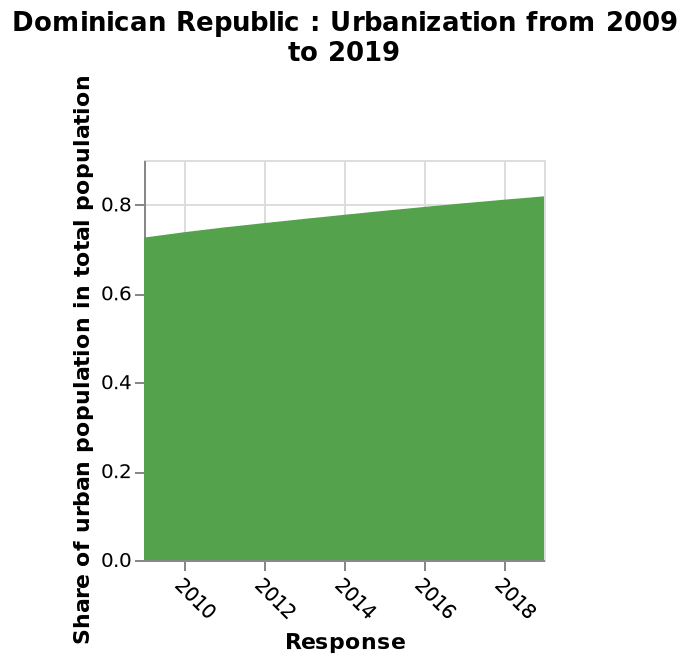<image>
How much has the share of urban population increased over the last 8 years?  The share of urban population has increased from 0.75 to 0.81 over the last 8 years. How would you describe the growth of urban population compared to total population since 2010? The growth of urban population compared to total population since 2010 has been steady. Describe the following image in detail This is a area plot named Dominican Republic : Urbanization from 2009 to 2019. The y-axis measures Share of urban population in total population on linear scale with a minimum of 0.0 and a maximum of 0.8 while the x-axis measures Response on linear scale of range 2010 to 2018. 